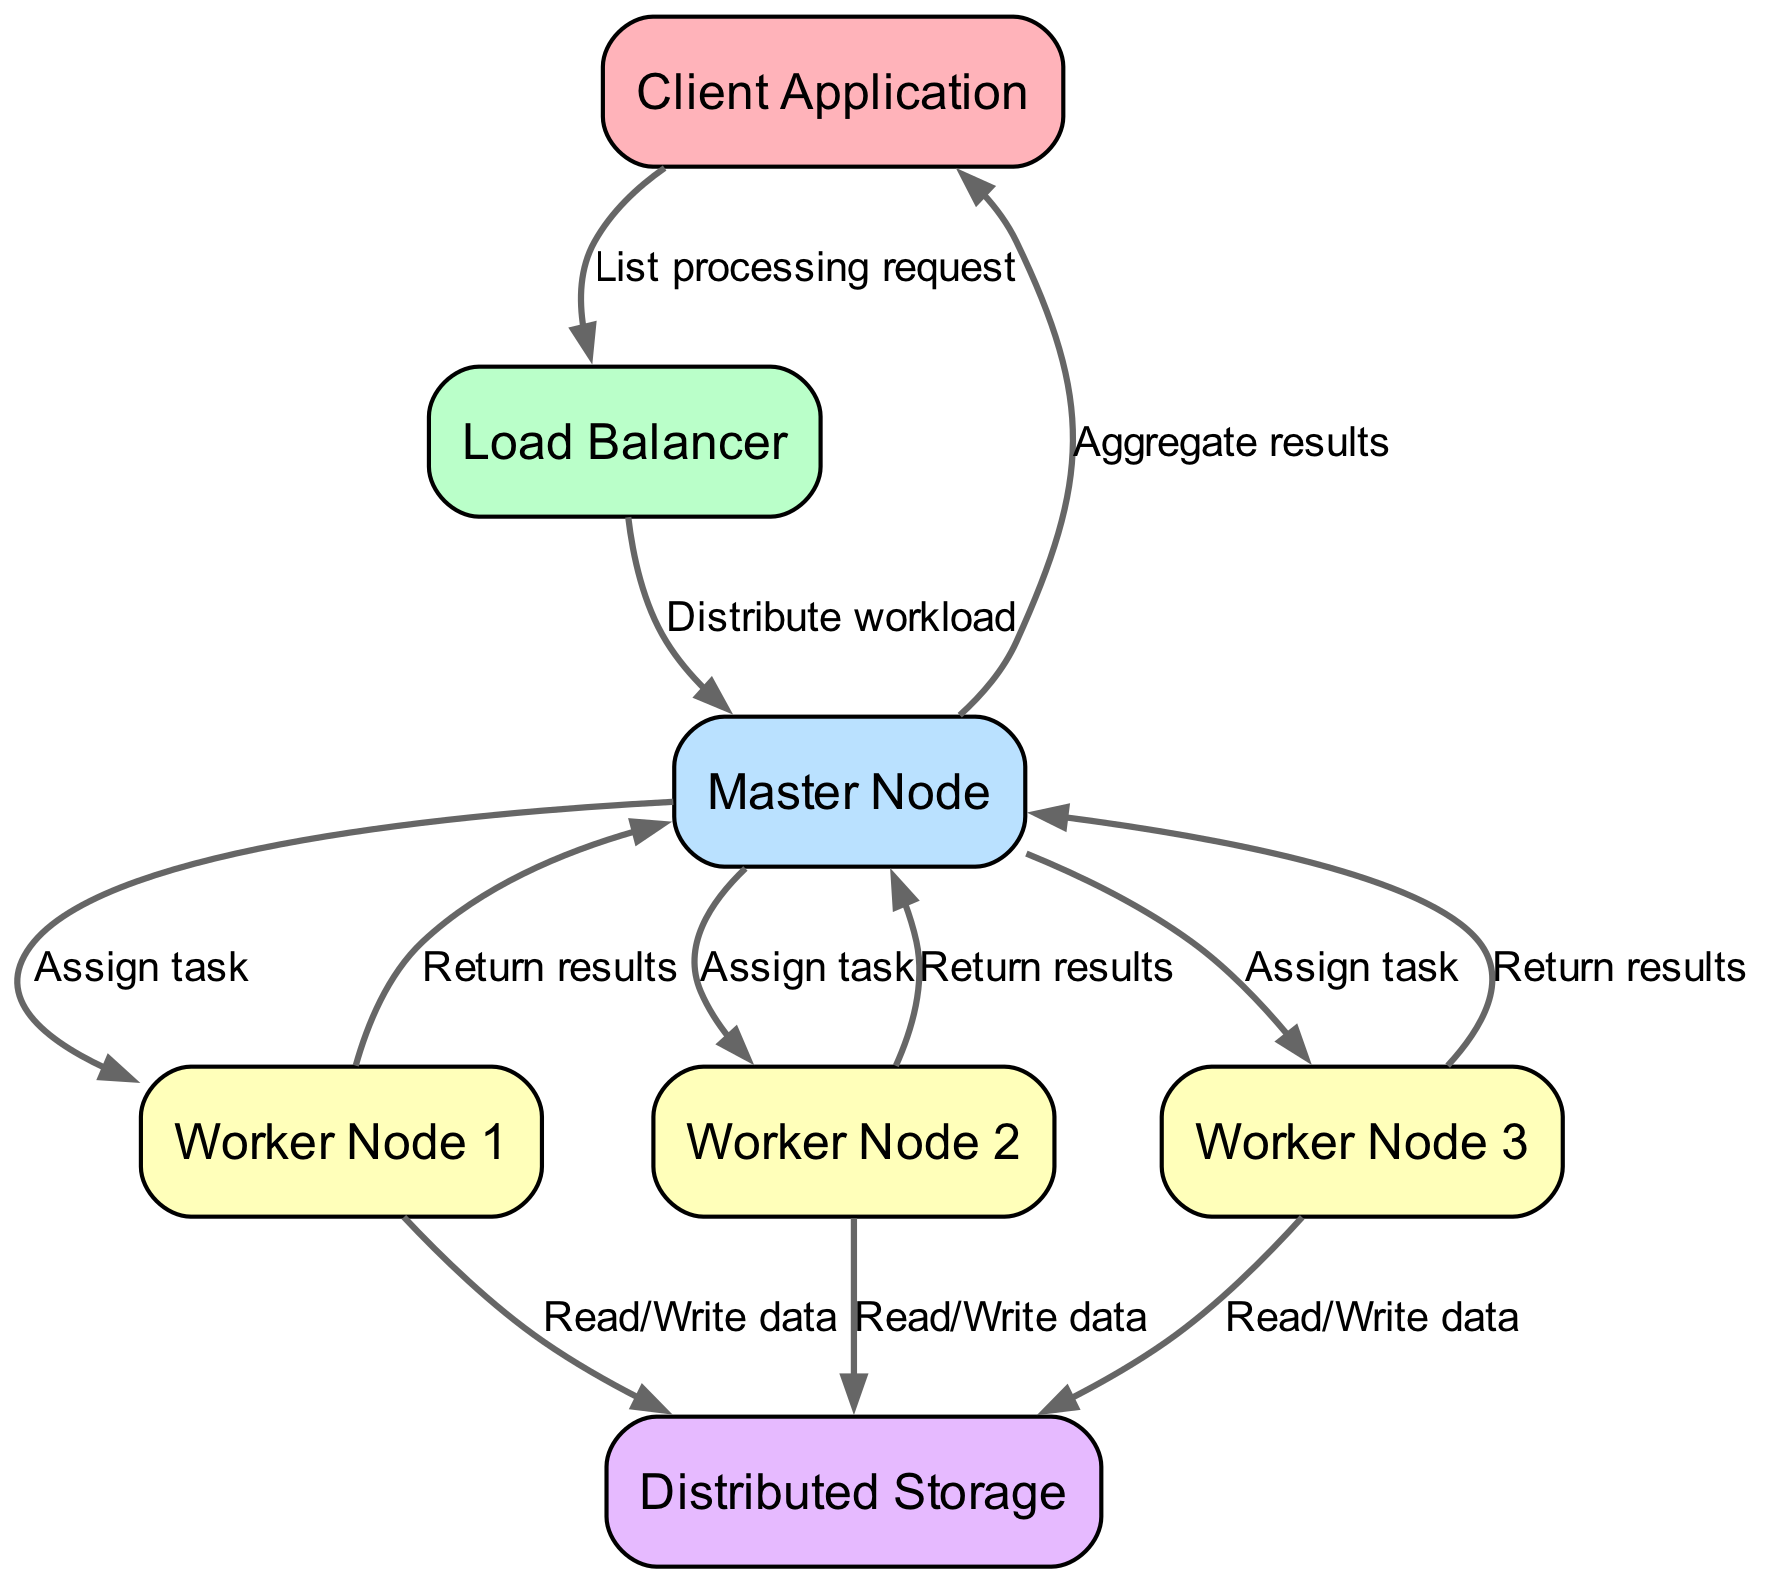What is the first node that receives the list processing request? The diagram shows an arrow leading from the "Client Application" to the "Load Balancer," indicating that the request originates from the client and goes to the load balancer first.
Answer: Load Balancer How many worker nodes are present in the diagram? The diagram includes three worker node labels: Worker Node 1, Worker Node 2, and Worker Node 3. A count of these nodes shows there are three in total.
Answer: 3 What type of operation is performed by the workers on the storage? The edges from each worker to the storage indicate the operation being carried out, which is "Read/Write data." Each worker node has a labeled connection to the storage node.
Answer: Read/Write data Which node aggregates results before sending them to the client? The "Master Node" is indicated in the diagram to have an outgoing edge labeled "Aggregate results," which means it is responsible for this function before communicating back to the client.
Answer: Master Node What is the data flow direction from the worker nodes to the master node? The edges from each worker node point towards the "Master Node," indicating that results or tasks are returned in the direction from the workers back to the master, which consolidates them.
Answer: From workers to master What does the "Load Balancer" do in this distributed system? The edges leading from the "Load Balancer" to the "Master Node" state that its function is to "Distribute workload," which highlights its role in balancing the task distribution among master and worker nodes.
Answer: Distribute workload How many total edges are there in the diagram? By counting each connection in the edges section: from the client to the load balancer, from the load balancer to the master node, and others, the total comes to 12 edges in the diagram.
Answer: 12 What is the relationship between the Master Node and the Client Application? The final step in the data flow from the "Master Node" to the "Client Application" is to "Aggregate results," which shows that the master node sends consolidated data back specifically to the client after processing.
Answer: Aggregate results What color represents the worker nodes in the diagram? The color assigned to the worker nodes in the diagram, as highlighted in the custom color palette, is "FFFFBA," which is a pale yellow, reflecting their category in the diagram.
Answer: FFFFBA 